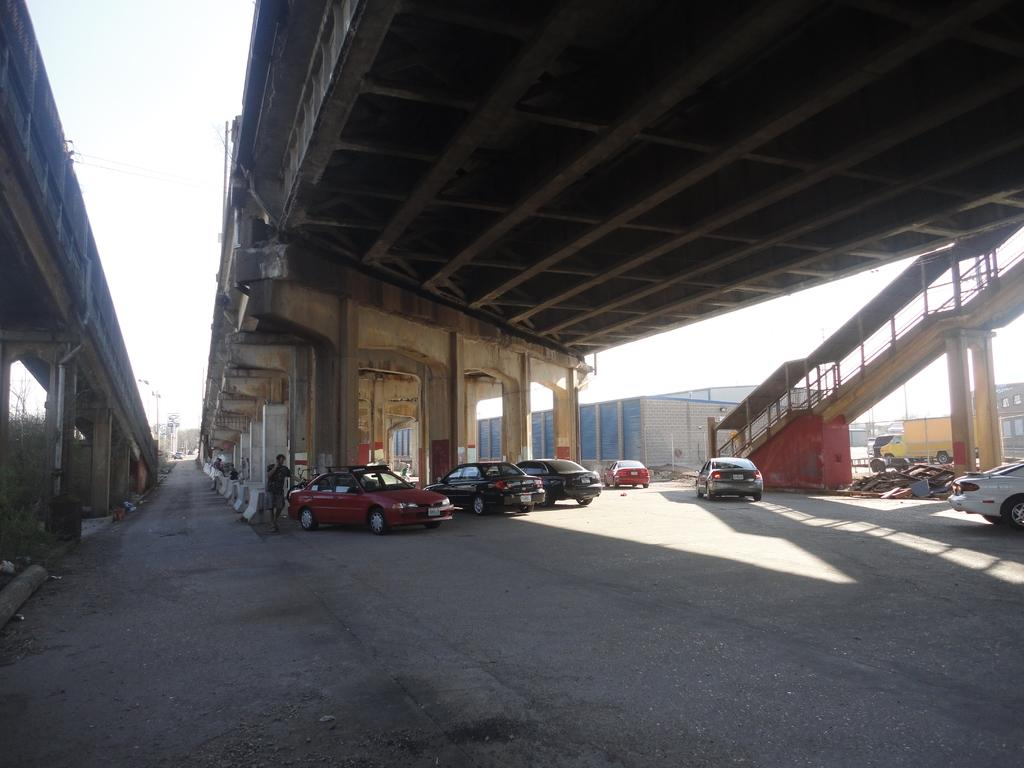What can be seen at the base of the image? The ground is visible in the image. What is present on the ground? There are vehicles on the ground. Can you describe the person in the image? There is a person standing in the image. What architectural features can be seen in the image? There are pillars in the image. How many bridges are visible in the image? There are two bridges in the image. What type of structures are present in the image? There are buildings in the image. What is visible in the background of the image? The sky is visible in the background of the image. What type of farmer is shown working on the stove in the image? There is no farmer or stove present in the image. What kind of bear can be seen interacting with the person in the image? There is no bear present in the image; only a person is visible. 